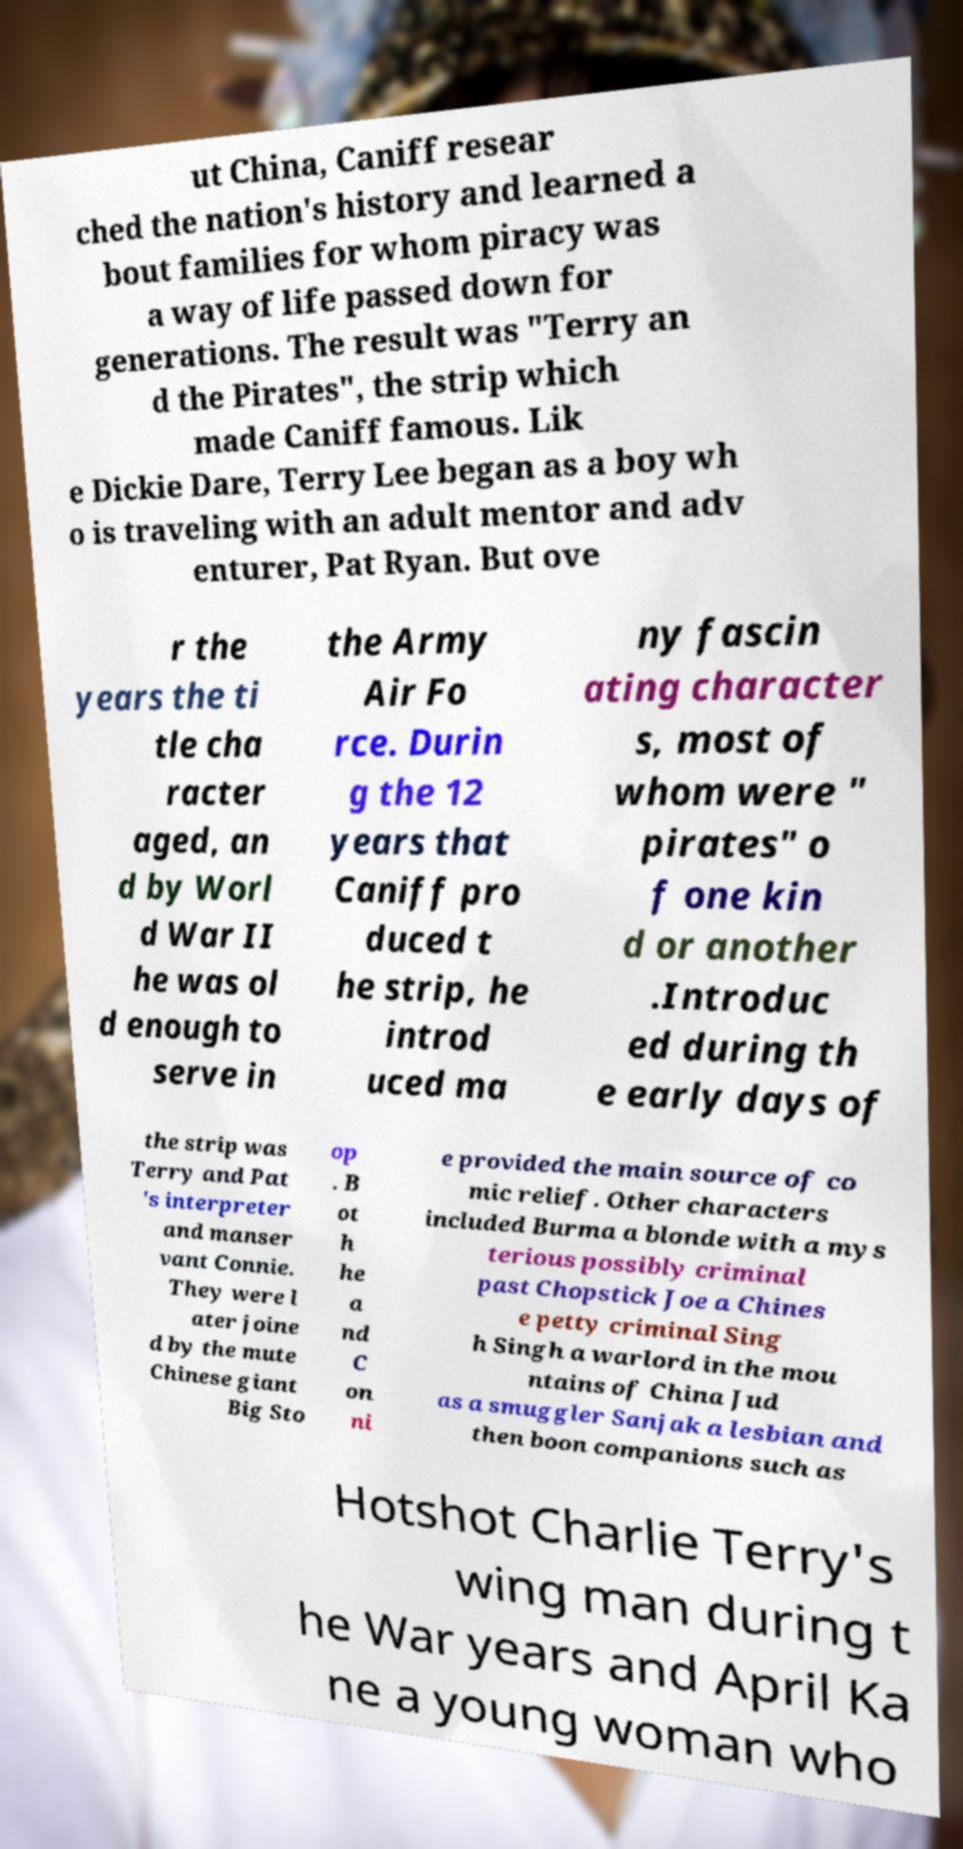What messages or text are displayed in this image? I need them in a readable, typed format. ut China, Caniff resear ched the nation's history and learned a bout families for whom piracy was a way of life passed down for generations. The result was "Terry an d the Pirates", the strip which made Caniff famous. Lik e Dickie Dare, Terry Lee began as a boy wh o is traveling with an adult mentor and adv enturer, Pat Ryan. But ove r the years the ti tle cha racter aged, an d by Worl d War II he was ol d enough to serve in the Army Air Fo rce. Durin g the 12 years that Caniff pro duced t he strip, he introd uced ma ny fascin ating character s, most of whom were " pirates" o f one kin d or another .Introduc ed during th e early days of the strip was Terry and Pat 's interpreter and manser vant Connie. They were l ater joine d by the mute Chinese giant Big Sto op . B ot h he a nd C on ni e provided the main source of co mic relief. Other characters included Burma a blonde with a mys terious possibly criminal past Chopstick Joe a Chines e petty criminal Sing h Singh a warlord in the mou ntains of China Jud as a smuggler Sanjak a lesbian and then boon companions such as Hotshot Charlie Terry's wing man during t he War years and April Ka ne a young woman who 